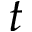<formula> <loc_0><loc_0><loc_500><loc_500>t</formula> 